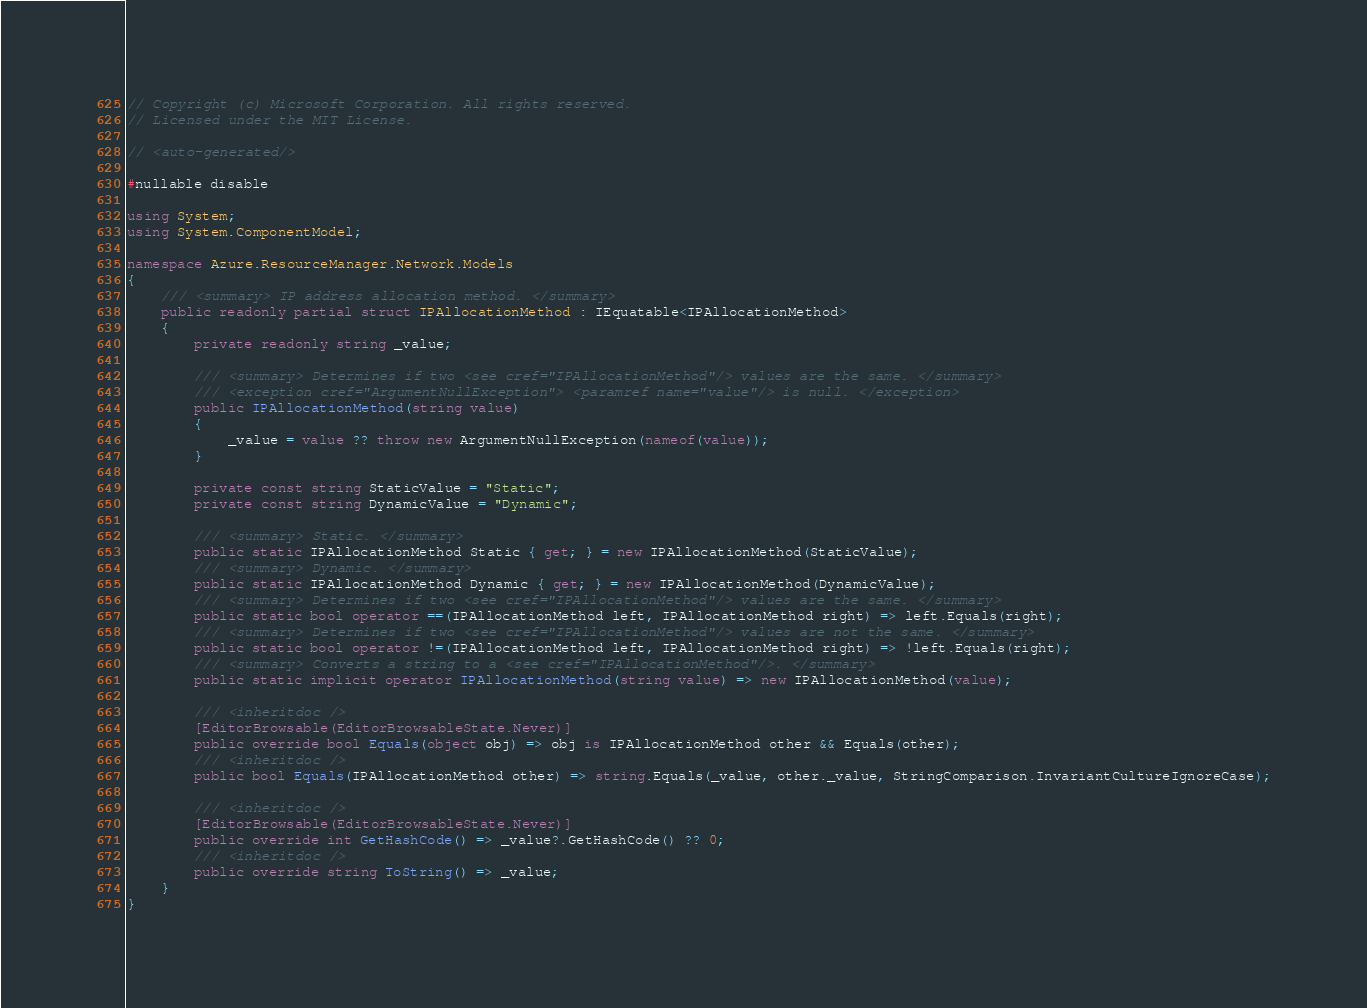<code> <loc_0><loc_0><loc_500><loc_500><_C#_>// Copyright (c) Microsoft Corporation. All rights reserved.
// Licensed under the MIT License.

// <auto-generated/>

#nullable disable

using System;
using System.ComponentModel;

namespace Azure.ResourceManager.Network.Models
{
    /// <summary> IP address allocation method. </summary>
    public readonly partial struct IPAllocationMethod : IEquatable<IPAllocationMethod>
    {
        private readonly string _value;

        /// <summary> Determines if two <see cref="IPAllocationMethod"/> values are the same. </summary>
        /// <exception cref="ArgumentNullException"> <paramref name="value"/> is null. </exception>
        public IPAllocationMethod(string value)
        {
            _value = value ?? throw new ArgumentNullException(nameof(value));
        }

        private const string StaticValue = "Static";
        private const string DynamicValue = "Dynamic";

        /// <summary> Static. </summary>
        public static IPAllocationMethod Static { get; } = new IPAllocationMethod(StaticValue);
        /// <summary> Dynamic. </summary>
        public static IPAllocationMethod Dynamic { get; } = new IPAllocationMethod(DynamicValue);
        /// <summary> Determines if two <see cref="IPAllocationMethod"/> values are the same. </summary>
        public static bool operator ==(IPAllocationMethod left, IPAllocationMethod right) => left.Equals(right);
        /// <summary> Determines if two <see cref="IPAllocationMethod"/> values are not the same. </summary>
        public static bool operator !=(IPAllocationMethod left, IPAllocationMethod right) => !left.Equals(right);
        /// <summary> Converts a string to a <see cref="IPAllocationMethod"/>. </summary>
        public static implicit operator IPAllocationMethod(string value) => new IPAllocationMethod(value);

        /// <inheritdoc />
        [EditorBrowsable(EditorBrowsableState.Never)]
        public override bool Equals(object obj) => obj is IPAllocationMethod other && Equals(other);
        /// <inheritdoc />
        public bool Equals(IPAllocationMethod other) => string.Equals(_value, other._value, StringComparison.InvariantCultureIgnoreCase);

        /// <inheritdoc />
        [EditorBrowsable(EditorBrowsableState.Never)]
        public override int GetHashCode() => _value?.GetHashCode() ?? 0;
        /// <inheritdoc />
        public override string ToString() => _value;
    }
}
</code> 